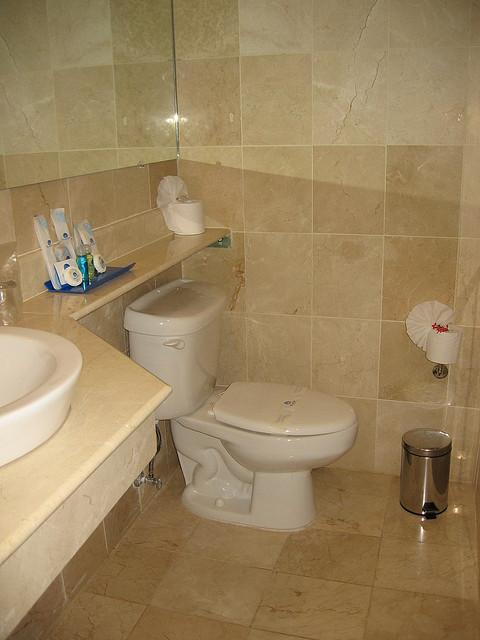Where is this bathroom located?

Choices:
A) hotel
B) home
C) hospital
D) park hotel 